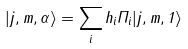Convert formula to latex. <formula><loc_0><loc_0><loc_500><loc_500>| j , m , \alpha \rangle = \sum _ { i } h _ { i } \Pi _ { i } | j , m , 1 \rangle</formula> 